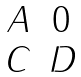Convert formula to latex. <formula><loc_0><loc_0><loc_500><loc_500>\begin{matrix} A & 0 \\ C & D \end{matrix}</formula> 